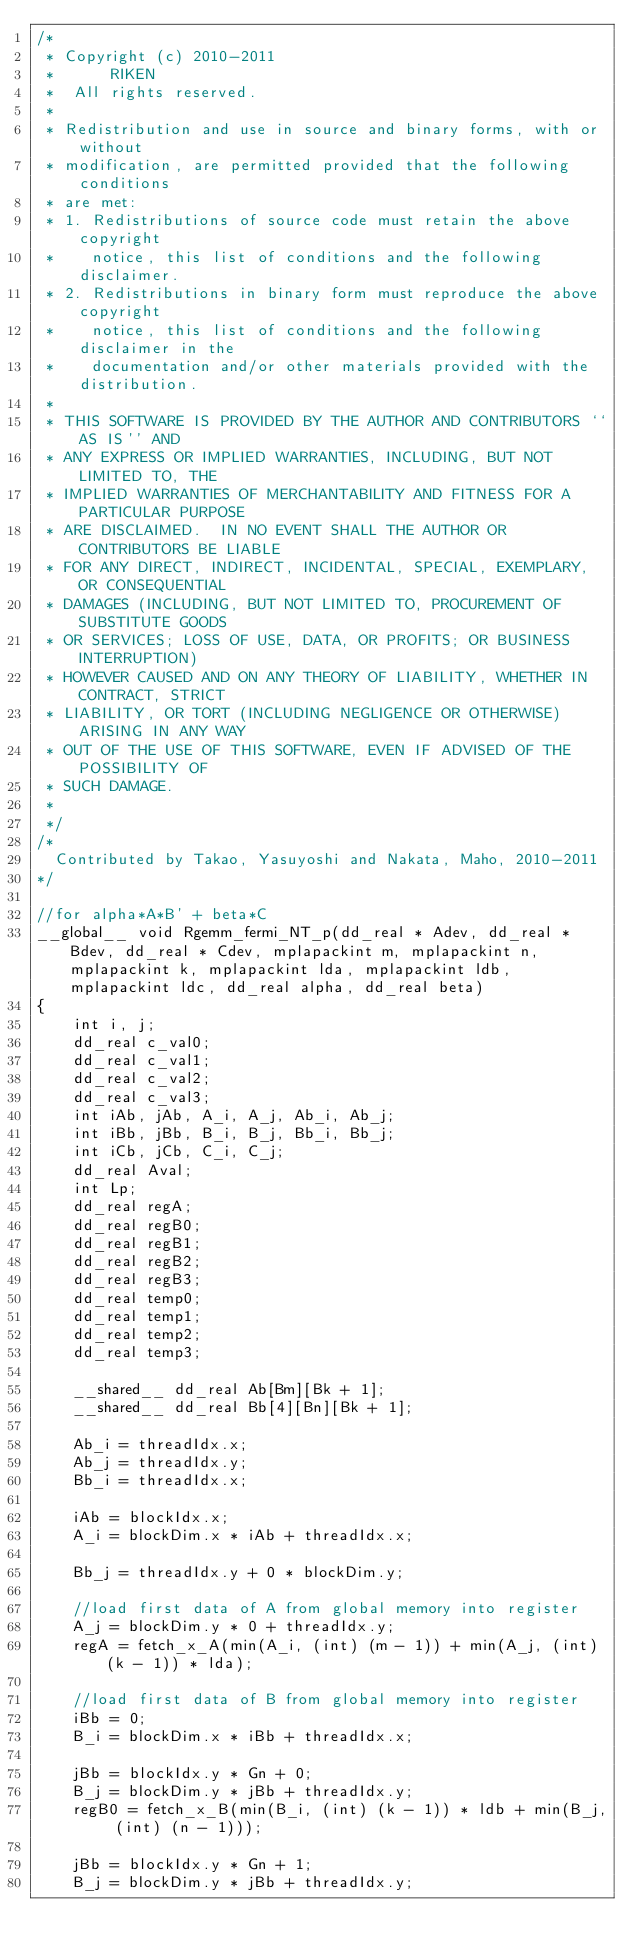Convert code to text. <code><loc_0><loc_0><loc_500><loc_500><_Cuda_>/*
 * Copyright (c) 2010-2011
 *      RIKEN
 * 	All rights reserved.
 *
 * Redistribution and use in source and binary forms, with or without
 * modification, are permitted provided that the following conditions
 * are met:
 * 1. Redistributions of source code must retain the above copyright
 *    notice, this list of conditions and the following disclaimer.
 * 2. Redistributions in binary form must reproduce the above copyright
 *    notice, this list of conditions and the following disclaimer in the
 *    documentation and/or other materials provided with the distribution.
 *
 * THIS SOFTWARE IS PROVIDED BY THE AUTHOR AND CONTRIBUTORS ``AS IS'' AND
 * ANY EXPRESS OR IMPLIED WARRANTIES, INCLUDING, BUT NOT LIMITED TO, THE
 * IMPLIED WARRANTIES OF MERCHANTABILITY AND FITNESS FOR A PARTICULAR PURPOSE
 * ARE DISCLAIMED.  IN NO EVENT SHALL THE AUTHOR OR CONTRIBUTORS BE LIABLE
 * FOR ANY DIRECT, INDIRECT, INCIDENTAL, SPECIAL, EXEMPLARY, OR CONSEQUENTIAL
 * DAMAGES (INCLUDING, BUT NOT LIMITED TO, PROCUREMENT OF SUBSTITUTE GOODS
 * OR SERVICES; LOSS OF USE, DATA, OR PROFITS; OR BUSINESS INTERRUPTION)
 * HOWEVER CAUSED AND ON ANY THEORY OF LIABILITY, WHETHER IN CONTRACT, STRICT
 * LIABILITY, OR TORT (INCLUDING NEGLIGENCE OR OTHERWISE) ARISING IN ANY WAY
 * OUT OF THE USE OF THIS SOFTWARE, EVEN IF ADVISED OF THE POSSIBILITY OF
 * SUCH DAMAGE.
 *
 */
/*
  Contributed by Takao, Yasuyoshi and Nakata, Maho, 2010-2011
*/

//for alpha*A*B' + beta*C
__global__ void Rgemm_fermi_NT_p(dd_real * Adev, dd_real * Bdev, dd_real * Cdev, mplapackint m, mplapackint n, mplapackint k, mplapackint lda, mplapackint ldb, mplapackint ldc, dd_real alpha, dd_real beta)
{
    int i, j;
    dd_real c_val0;
    dd_real c_val1;
    dd_real c_val2;
    dd_real c_val3;
    int iAb, jAb, A_i, A_j, Ab_i, Ab_j;
    int iBb, jBb, B_i, B_j, Bb_i, Bb_j;
    int iCb, jCb, C_i, C_j;
    dd_real Aval;
    int Lp;
    dd_real regA;
    dd_real regB0;
    dd_real regB1;
    dd_real regB2;
    dd_real regB3;
    dd_real temp0;
    dd_real temp1;
    dd_real temp2;
    dd_real temp3;

    __shared__ dd_real Ab[Bm][Bk + 1];
    __shared__ dd_real Bb[4][Bn][Bk + 1];

    Ab_i = threadIdx.x;
    Ab_j = threadIdx.y;
    Bb_i = threadIdx.x;

    iAb = blockIdx.x;
    A_i = blockDim.x * iAb + threadIdx.x;

    Bb_j = threadIdx.y + 0 * blockDim.y;

    //load first data of A from global memory into register
    A_j = blockDim.y * 0 + threadIdx.y;
    regA = fetch_x_A(min(A_i, (int) (m - 1)) + min(A_j, (int) (k - 1)) * lda);

    //load first data of B from global memory into register
    iBb = 0;
    B_i = blockDim.x * iBb + threadIdx.x;

    jBb = blockIdx.y * Gn + 0;
    B_j = blockDim.y * jBb + threadIdx.y;
    regB0 = fetch_x_B(min(B_i, (int) (k - 1)) * ldb + min(B_j, (int) (n - 1)));

    jBb = blockIdx.y * Gn + 1;
    B_j = blockDim.y * jBb + threadIdx.y;</code> 